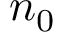<formula> <loc_0><loc_0><loc_500><loc_500>n _ { 0 }</formula> 